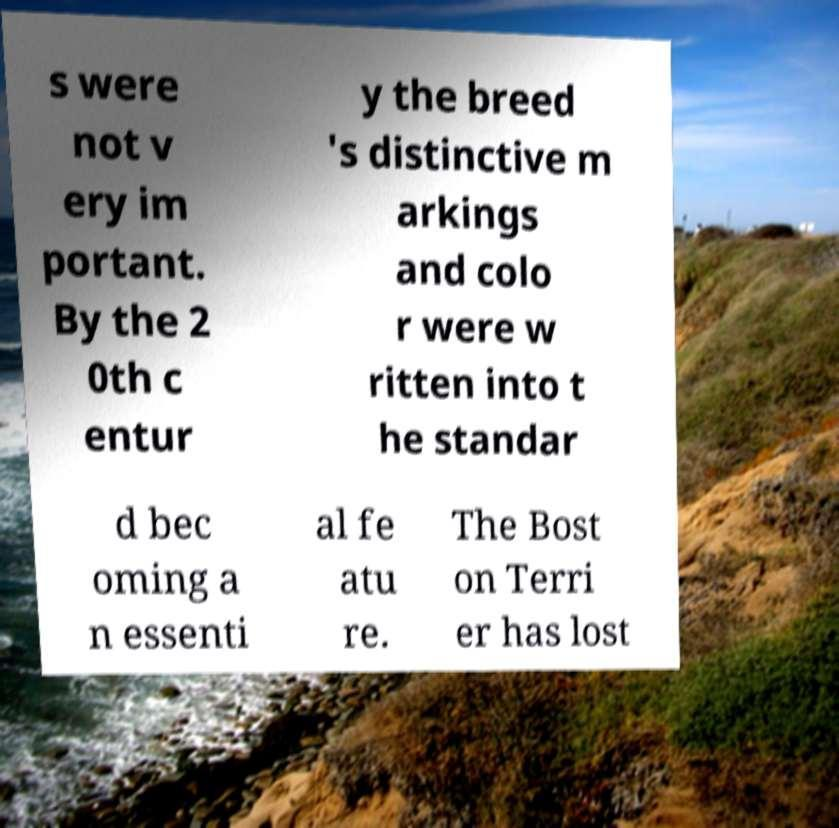There's text embedded in this image that I need extracted. Can you transcribe it verbatim? s were not v ery im portant. By the 2 0th c entur y the breed 's distinctive m arkings and colo r were w ritten into t he standar d bec oming a n essenti al fe atu re. The Bost on Terri er has lost 